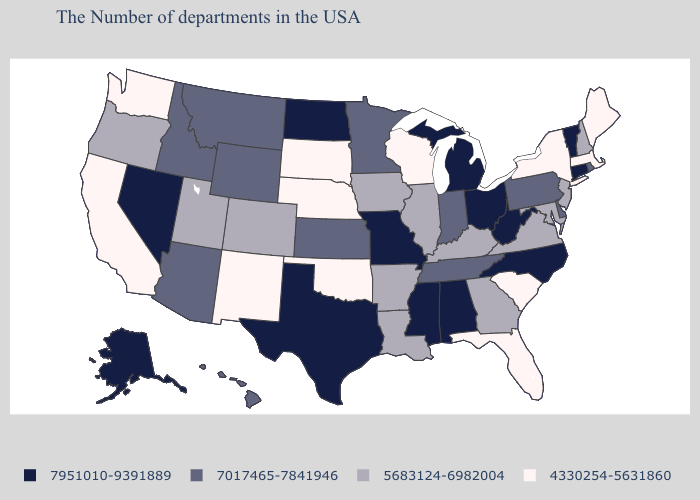Among the states that border Wyoming , does Montana have the lowest value?
Quick response, please. No. Does Ohio have the highest value in the MidWest?
Write a very short answer. Yes. What is the value of Hawaii?
Quick response, please. 7017465-7841946. Does North Carolina have the lowest value in the USA?
Write a very short answer. No. Does Alaska have the lowest value in the USA?
Concise answer only. No. What is the value of New Hampshire?
Answer briefly. 5683124-6982004. Does Alabama have a higher value than Wisconsin?
Be succinct. Yes. Which states have the lowest value in the USA?
Answer briefly. Maine, Massachusetts, New York, South Carolina, Florida, Wisconsin, Nebraska, Oklahoma, South Dakota, New Mexico, California, Washington. What is the value of Washington?
Be succinct. 4330254-5631860. Does Connecticut have the highest value in the USA?
Give a very brief answer. Yes. What is the lowest value in the West?
Be succinct. 4330254-5631860. Which states have the lowest value in the USA?
Give a very brief answer. Maine, Massachusetts, New York, South Carolina, Florida, Wisconsin, Nebraska, Oklahoma, South Dakota, New Mexico, California, Washington. Does South Dakota have the lowest value in the USA?
Short answer required. Yes. What is the value of Alaska?
Answer briefly. 7951010-9391889. What is the highest value in states that border Maryland?
Keep it brief. 7951010-9391889. 